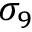<formula> <loc_0><loc_0><loc_500><loc_500>\sigma _ { 9 }</formula> 